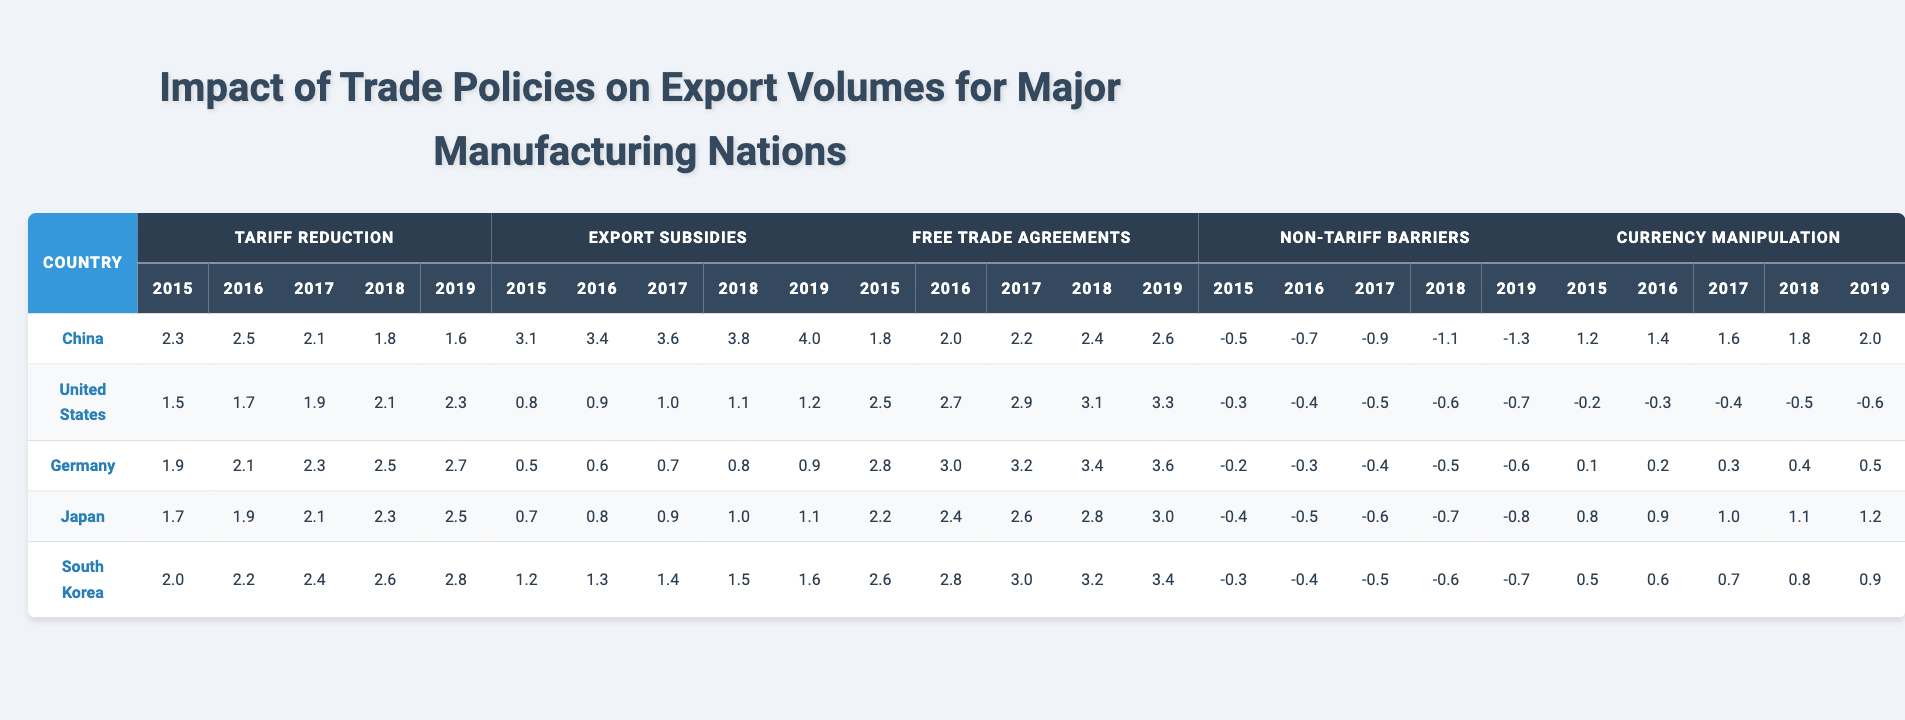What was the highest export subsidy value for China in 2019? The table shows that in 2019, the export subsidy value for China is 4.0. This is the specific figure listed in the relevant cell.
Answer: 4.0 What was the average tariff reduction value for Germany over the years 2015 to 2019? To find the average tariff reduction for Germany, add the values from 2015 to 2019, which are (1.9 + 2.1 + 2.3 + 2.5 + 2.7) = 11.5. Then, divide by 5 (the number of years), resulting in 11.5 / 5 = 2.3.
Answer: 2.3 Which country had the lowest value in non-tariff barriers in 2018? The table shows that China had the lowest non-tariff barrier value in 2018 at -1.1. By comparing values of all countries for that year, it is clear that China's is the lowest.
Answer: China Were there any instances where currency manipulation values were negative for any country in the years 2015 to 2019? Checking the currency manipulation values, the United States shows negative values in every year from 2015 to 2019. Thus, the answer is yes, there were instances of negative values.
Answer: Yes What is the difference in free trade agreement values between Japan and South Korea in 2017? In 2017, Japan had a free trade agreement value of 2.6, and South Korea had a value of 3.0. Subtracting Japan's value from South Korea's value gives 3.0 - 2.6 = 0.4.
Answer: 0.4 Which country showed the most consistent increase in export subsidy values from 2015 to 2019? Looking at the export subsidy values over the years for each country, China steadily increased each year: 3.1, 3.4, 3.6, 3.8, 4.0. This consistent upward trend indicates that China had the most consistent increase.
Answer: China In 2019, what was the average value of tariff reductions across all countries? The tariff reduction values in 2019 were: China (1.6), United States (2.3), Germany (2.7), Japan (2.5), and South Korea (2.8). Adding these gives 11.0, then divide by 5 which results in an average of 11.0 / 5 = 2.2.
Answer: 2.2 What trend can be observed in currency manipulation values for China over the years provided? The currency manipulation values for China show a steady increase from 1.2 in 2015 to 2.0 in 2019. Thus, the trend indicates a consistent increase over these years.
Answer: Increase Which country had the highest free trade agreement value in 2016? The table shows that Germany had the highest value for free trade agreements in 2016, with a value of 3.0, which is greater than those of the other countries for that year.
Answer: Germany Is it true that all countries experienced a decrease in non-tariff barriers from 2015 to 2019? Analyzing the non-tariff barrier values, all show a downward trend over the years. This indicates that the statement is true.
Answer: True 